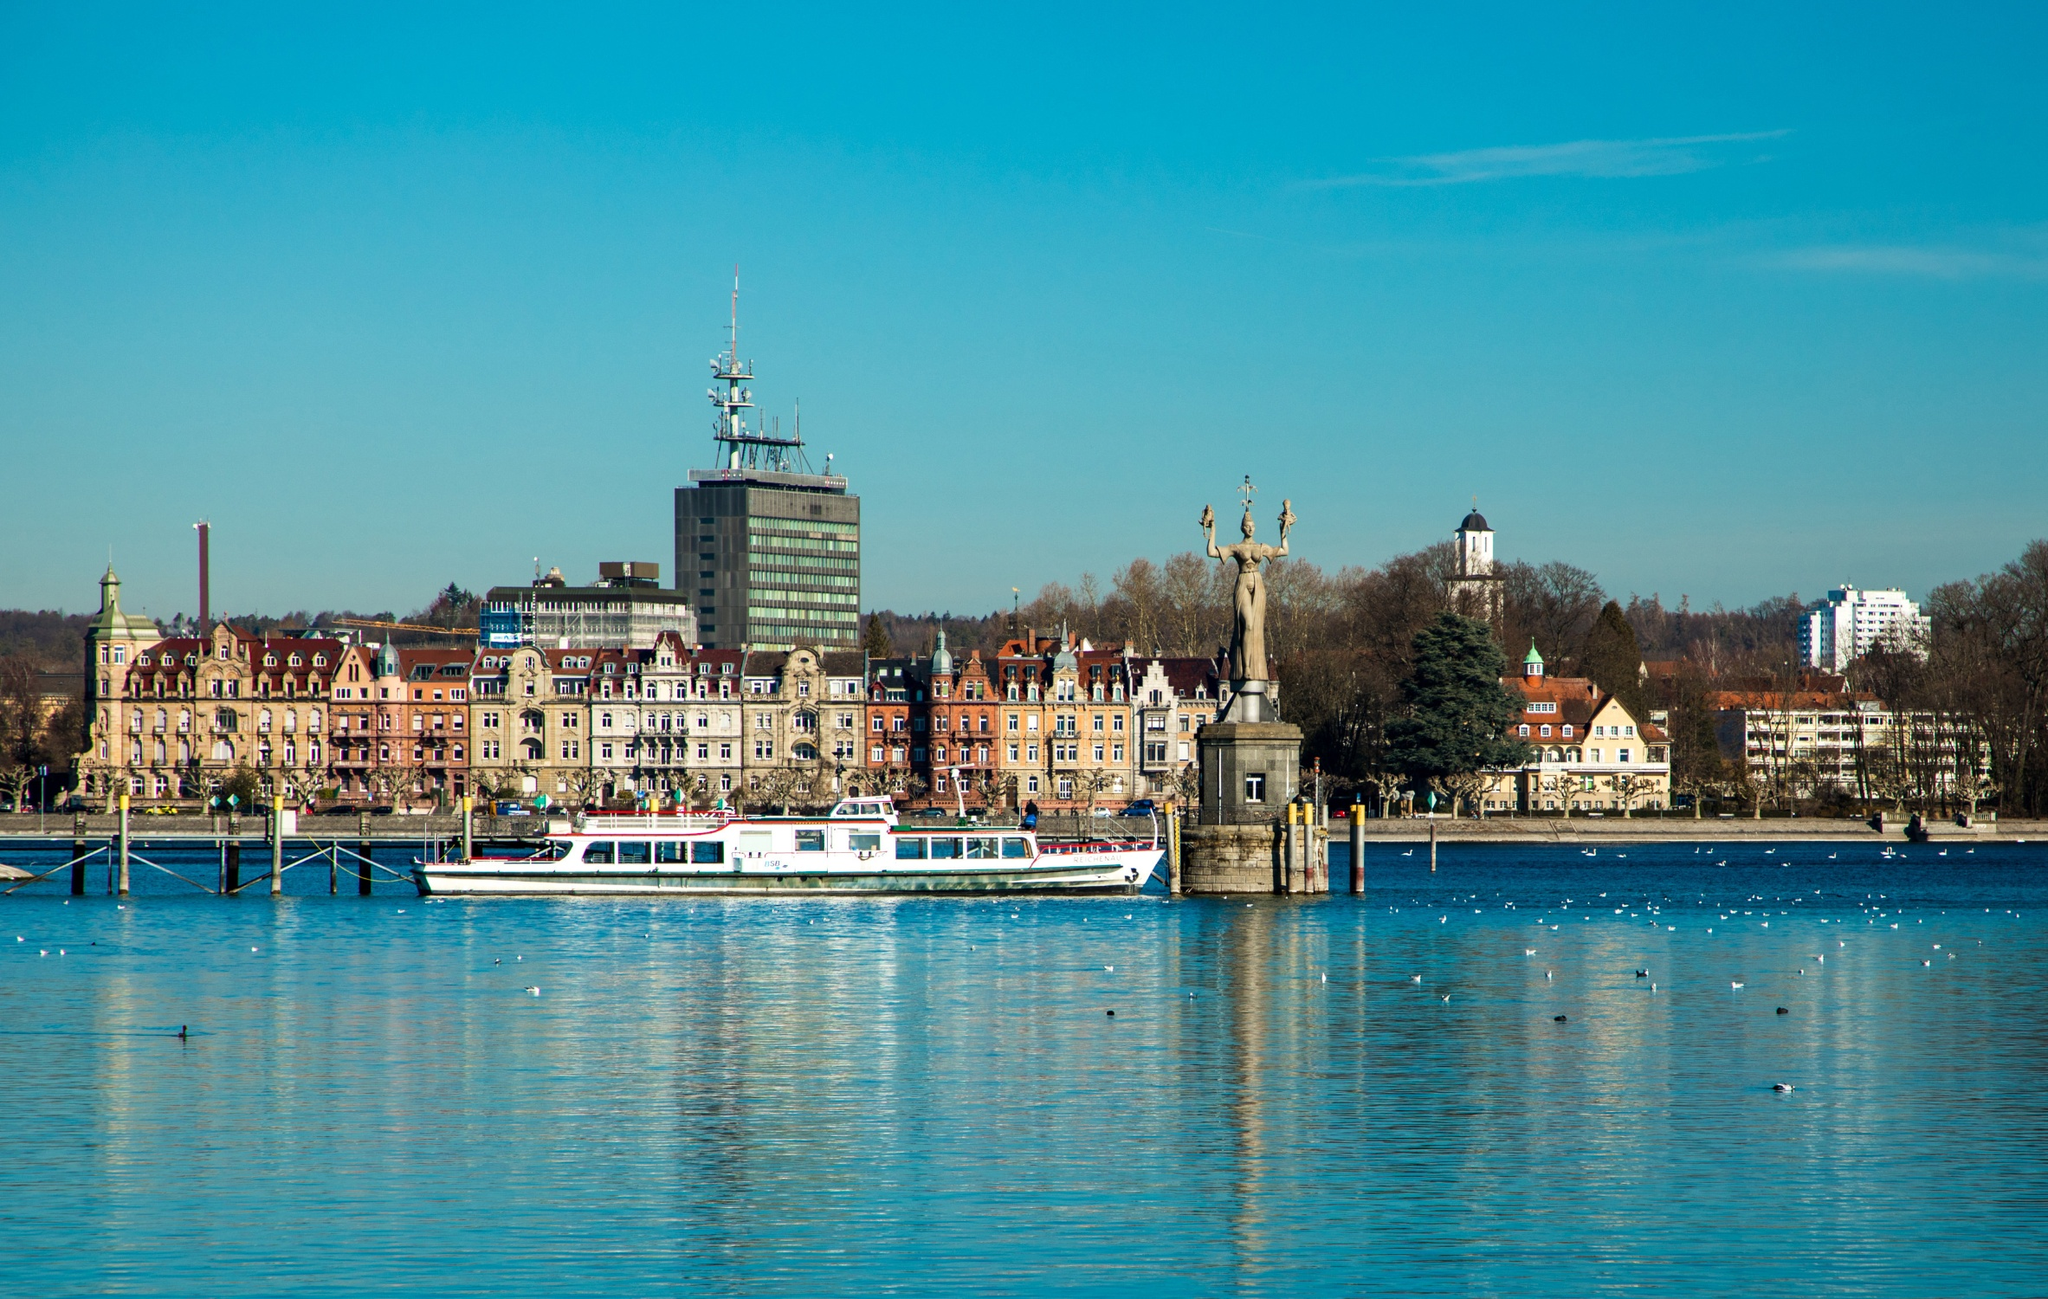Create a poetic description inspired by the image, focusing on the serene nature of the harbour. Beneath the azure dome, where heaven kisses the earth,\nLies Constance Harbour, in tranquil, gentle mirth.\nThe waters whisper secrets, of times long past and gone,\nReflecting skies of sapphire, in early morning dawn.\nThe city stands in silence, with tales in every stone,\nA fusion of old and new, in majesty alone.\nA boat glides soft as whispers, on the cradle of the blue,\nWhile statues stand as sentinels, with histories to imbue.\nIn colors pure and tender, where sky and water meet,\nA peaceful hymn of nature, in the city’s silent beat.\nThe harbor sings a lullaby, in shades of blue and white,\nA timeless, endless reverie, in the soft embrace of light. 